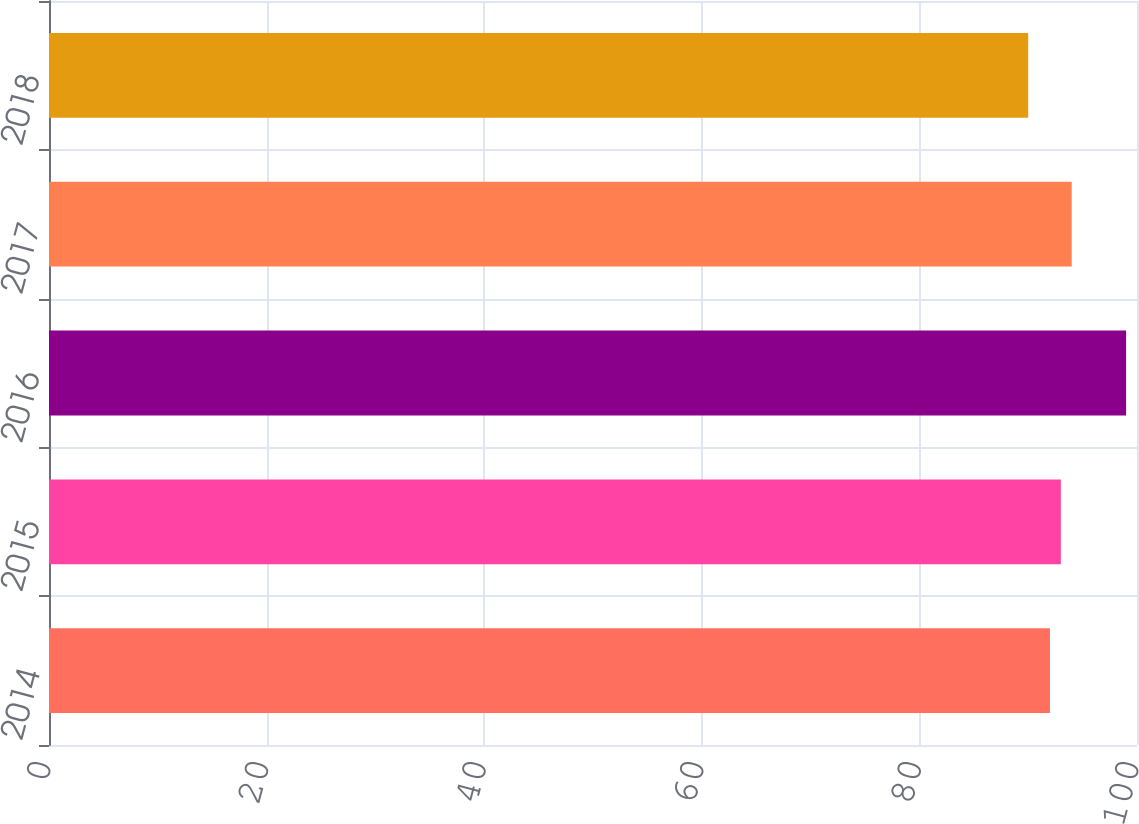Convert chart. <chart><loc_0><loc_0><loc_500><loc_500><bar_chart><fcel>2014<fcel>2015<fcel>2016<fcel>2017<fcel>2018<nl><fcel>92<fcel>93<fcel>99<fcel>94<fcel>90<nl></chart> 